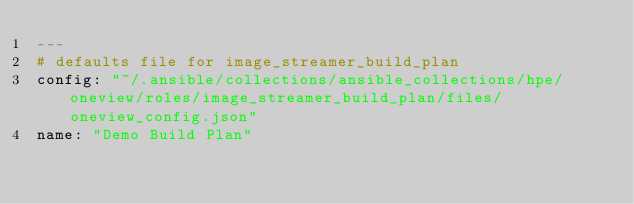Convert code to text. <code><loc_0><loc_0><loc_500><loc_500><_YAML_>---
# defaults file for image_streamer_build_plan
config: "~/.ansible/collections/ansible_collections/hpe/oneview/roles/image_streamer_build_plan/files/oneview_config.json"
name: "Demo Build Plan"</code> 